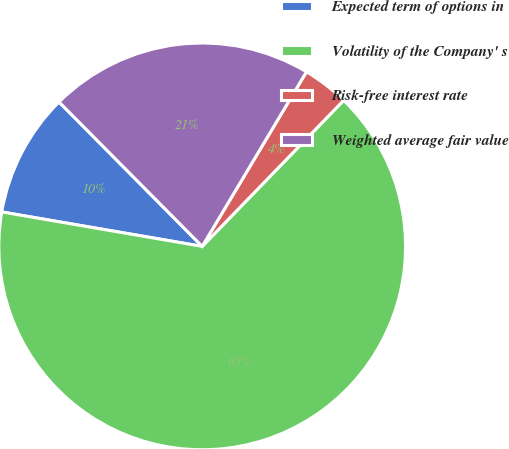Convert chart to OTSL. <chart><loc_0><loc_0><loc_500><loc_500><pie_chart><fcel>Expected term of options in<fcel>Volatility of the Company' s<fcel>Risk-free interest rate<fcel>Weighted average fair value<nl><fcel>9.86%<fcel>65.46%<fcel>3.68%<fcel>21.0%<nl></chart> 